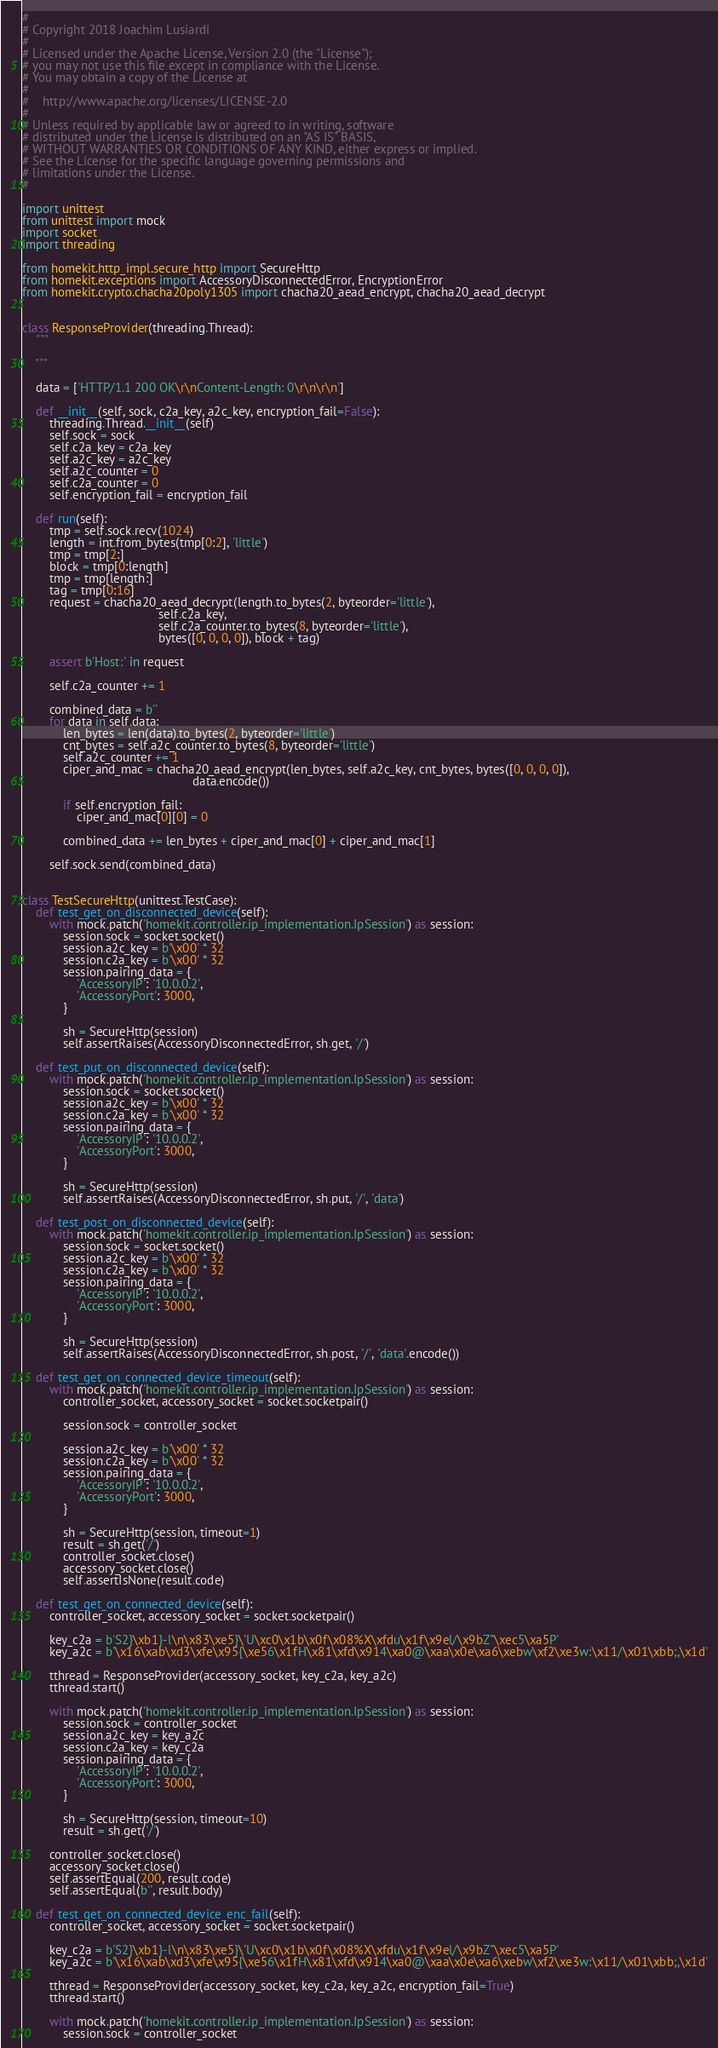<code> <loc_0><loc_0><loc_500><loc_500><_Python_>#
# Copyright 2018 Joachim Lusiardi
#
# Licensed under the Apache License, Version 2.0 (the "License");
# you may not use this file except in compliance with the License.
# You may obtain a copy of the License at
#
#    http://www.apache.org/licenses/LICENSE-2.0
#
# Unless required by applicable law or agreed to in writing, software
# distributed under the License is distributed on an "AS IS" BASIS,
# WITHOUT WARRANTIES OR CONDITIONS OF ANY KIND, either express or implied.
# See the License for the specific language governing permissions and
# limitations under the License.
#

import unittest
from unittest import mock
import socket
import threading

from homekit.http_impl.secure_http import SecureHttp
from homekit.exceptions import AccessoryDisconnectedError, EncryptionError
from homekit.crypto.chacha20poly1305 import chacha20_aead_encrypt, chacha20_aead_decrypt


class ResponseProvider(threading.Thread):
    """

    """

    data = ['HTTP/1.1 200 OK\r\nContent-Length: 0\r\n\r\n']

    def __init__(self, sock, c2a_key, a2c_key, encryption_fail=False):
        threading.Thread.__init__(self)
        self.sock = sock
        self.c2a_key = c2a_key
        self.a2c_key = a2c_key
        self.a2c_counter = 0
        self.c2a_counter = 0
        self.encryption_fail = encryption_fail

    def run(self):
        tmp = self.sock.recv(1024)
        length = int.from_bytes(tmp[0:2], 'little')
        tmp = tmp[2:]
        block = tmp[0:length]
        tmp = tmp[length:]
        tag = tmp[0:16]
        request = chacha20_aead_decrypt(length.to_bytes(2, byteorder='little'),
                                        self.c2a_key,
                                        self.c2a_counter.to_bytes(8, byteorder='little'),
                                        bytes([0, 0, 0, 0]), block + tag)

        assert b'Host:' in request

        self.c2a_counter += 1

        combined_data = b''
        for data in self.data:
            len_bytes = len(data).to_bytes(2, byteorder='little')
            cnt_bytes = self.a2c_counter.to_bytes(8, byteorder='little')
            self.a2c_counter += 1
            ciper_and_mac = chacha20_aead_encrypt(len_bytes, self.a2c_key, cnt_bytes, bytes([0, 0, 0, 0]),
                                                  data.encode())

            if self.encryption_fail:
                ciper_and_mac[0][0] = 0

            combined_data += len_bytes + ciper_and_mac[0] + ciper_and_mac[1]

        self.sock.send(combined_data)


class TestSecureHttp(unittest.TestCase):
    def test_get_on_disconnected_device(self):
        with mock.patch('homekit.controller.ip_implementation.IpSession') as session:
            session.sock = socket.socket()
            session.a2c_key = b'\x00' * 32
            session.c2a_key = b'\x00' * 32
            session.pairing_data = {
                'AccessoryIP': '10.0.0.2',
                'AccessoryPort': 3000,
            }

            sh = SecureHttp(session)
            self.assertRaises(AccessoryDisconnectedError, sh.get, '/')

    def test_put_on_disconnected_device(self):
        with mock.patch('homekit.controller.ip_implementation.IpSession') as session:
            session.sock = socket.socket()
            session.a2c_key = b'\x00' * 32
            session.c2a_key = b'\x00' * 32
            session.pairing_data = {
                'AccessoryIP': '10.0.0.2',
                'AccessoryPort': 3000,
            }

            sh = SecureHttp(session)
            self.assertRaises(AccessoryDisconnectedError, sh.put, '/', 'data')

    def test_post_on_disconnected_device(self):
        with mock.patch('homekit.controller.ip_implementation.IpSession') as session:
            session.sock = socket.socket()
            session.a2c_key = b'\x00' * 32
            session.c2a_key = b'\x00' * 32
            session.pairing_data = {
                'AccessoryIP': '10.0.0.2',
                'AccessoryPort': 3000,
            }

            sh = SecureHttp(session)
            self.assertRaises(AccessoryDisconnectedError, sh.post, '/', 'data'.encode())

    def test_get_on_connected_device_timeout(self):
        with mock.patch('homekit.controller.ip_implementation.IpSession') as session:
            controller_socket, accessory_socket = socket.socketpair()

            session.sock = controller_socket

            session.a2c_key = b'\x00' * 32
            session.c2a_key = b'\x00' * 32
            session.pairing_data = {
                'AccessoryIP': '10.0.0.2',
                'AccessoryPort': 3000,
            }

            sh = SecureHttp(session, timeout=1)
            result = sh.get('/')
            controller_socket.close()
            accessory_socket.close()
            self.assertIsNone(result.code)

    def test_get_on_connected_device(self):
        controller_socket, accessory_socket = socket.socketpair()

        key_c2a = b'S2}\xb1}-l\n\x83\xe5}\'U\xc0\x1b\x0f\x08%X\xfdu\x1f\x9el/\x9bZ"\xec5\xa5P'
        key_a2c = b'\x16\xab\xd3\xfe\x95{\xe56\x1fH\x81\xfd\x914\xa0@\xaa\x0e\xa6\xebw\xf2\xe3w:\x11/\x01\xbb;,\x1d'

        tthread = ResponseProvider(accessory_socket, key_c2a, key_a2c)
        tthread.start()

        with mock.patch('homekit.controller.ip_implementation.IpSession') as session:
            session.sock = controller_socket
            session.a2c_key = key_a2c
            session.c2a_key = key_c2a
            session.pairing_data = {
                'AccessoryIP': '10.0.0.2',
                'AccessoryPort': 3000,
            }

            sh = SecureHttp(session, timeout=10)
            result = sh.get('/')

        controller_socket.close()
        accessory_socket.close()
        self.assertEqual(200, result.code)
        self.assertEqual(b'', result.body)

    def test_get_on_connected_device_enc_fail(self):
        controller_socket, accessory_socket = socket.socketpair()

        key_c2a = b'S2}\xb1}-l\n\x83\xe5}\'U\xc0\x1b\x0f\x08%X\xfdu\x1f\x9el/\x9bZ"\xec5\xa5P'
        key_a2c = b'\x16\xab\xd3\xfe\x95{\xe56\x1fH\x81\xfd\x914\xa0@\xaa\x0e\xa6\xebw\xf2\xe3w:\x11/\x01\xbb;,\x1d'

        tthread = ResponseProvider(accessory_socket, key_c2a, key_a2c, encryption_fail=True)
        tthread.start()

        with mock.patch('homekit.controller.ip_implementation.IpSession') as session:
            session.sock = controller_socket</code> 